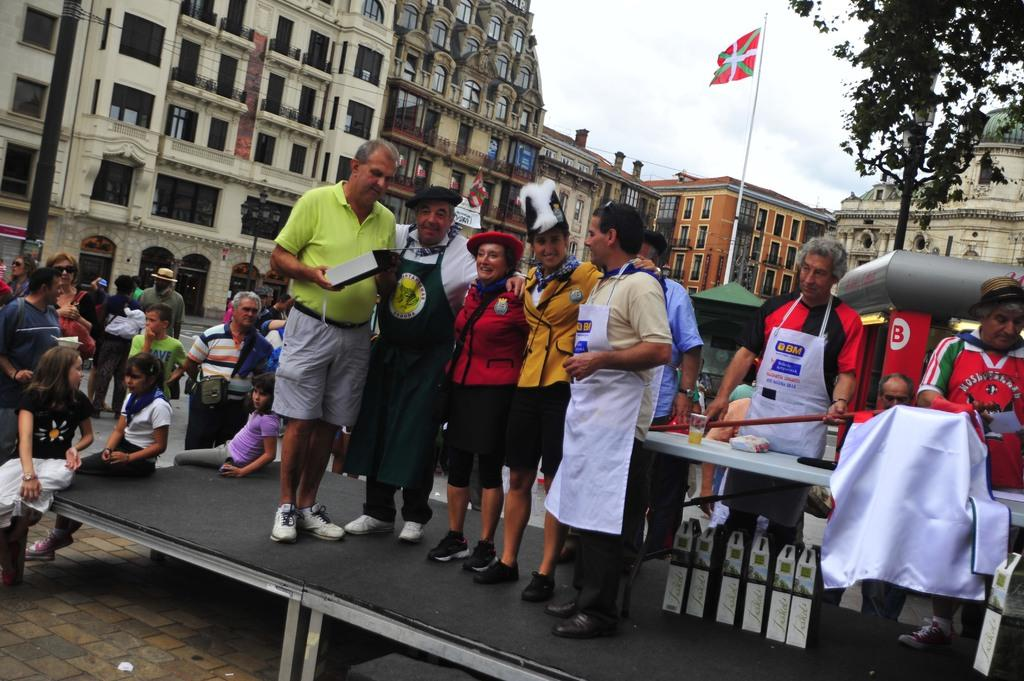What are the people in the image doing? The people are standing on the stage in the image. What can be seen in the background of the image? Buildings are visible in the image. What is the flag associated with? The flag is present in the image. What type of transportation is visible in the image? Vehicles are present in the image. What type of plant is in the image? There is a tree in the image. What type of mint is growing near the tree in the image? There is no mint present in the image. What type of ray is visible in the sky in the image? There is no ray visible in the sky in the image. 